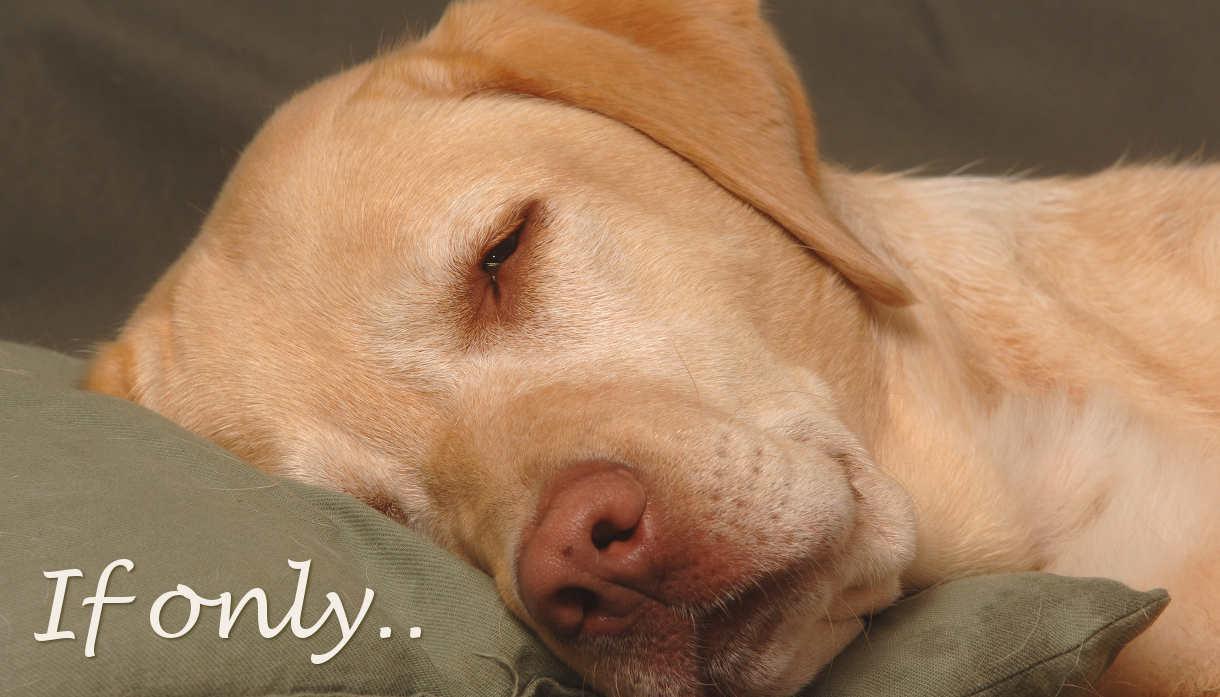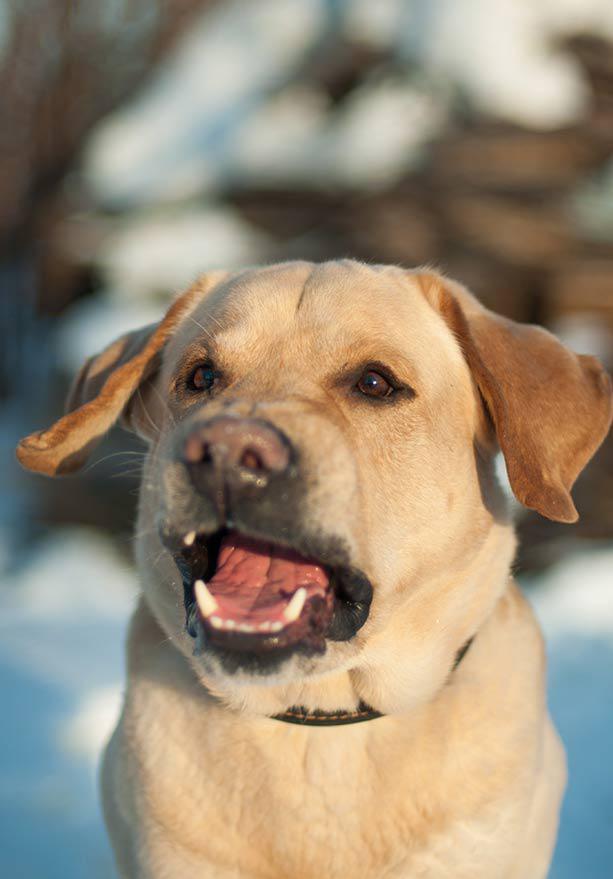The first image is the image on the left, the second image is the image on the right. For the images shown, is this caption "Only one image shows a dog with mouth opened." true? Answer yes or no. Yes. The first image is the image on the left, the second image is the image on the right. Assess this claim about the two images: "The dog on the right is on the grass.". Correct or not? Answer yes or no. No. 